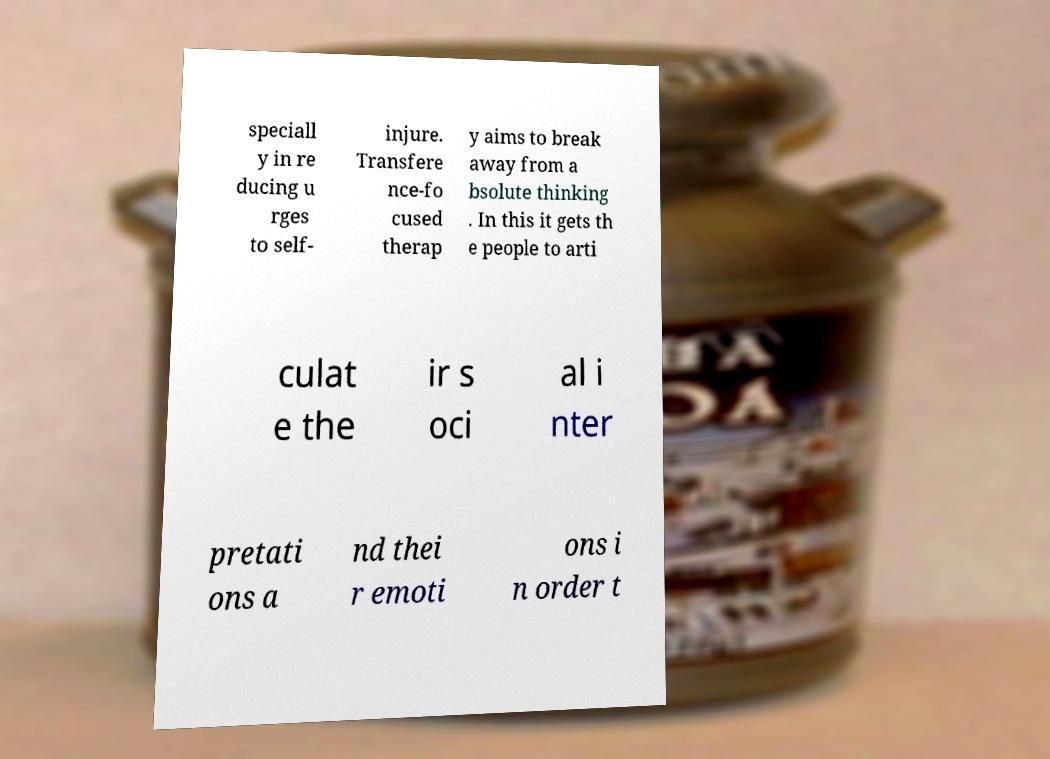There's text embedded in this image that I need extracted. Can you transcribe it verbatim? speciall y in re ducing u rges to self- injure. Transfere nce-fo cused therap y aims to break away from a bsolute thinking . In this it gets th e people to arti culat e the ir s oci al i nter pretati ons a nd thei r emoti ons i n order t 